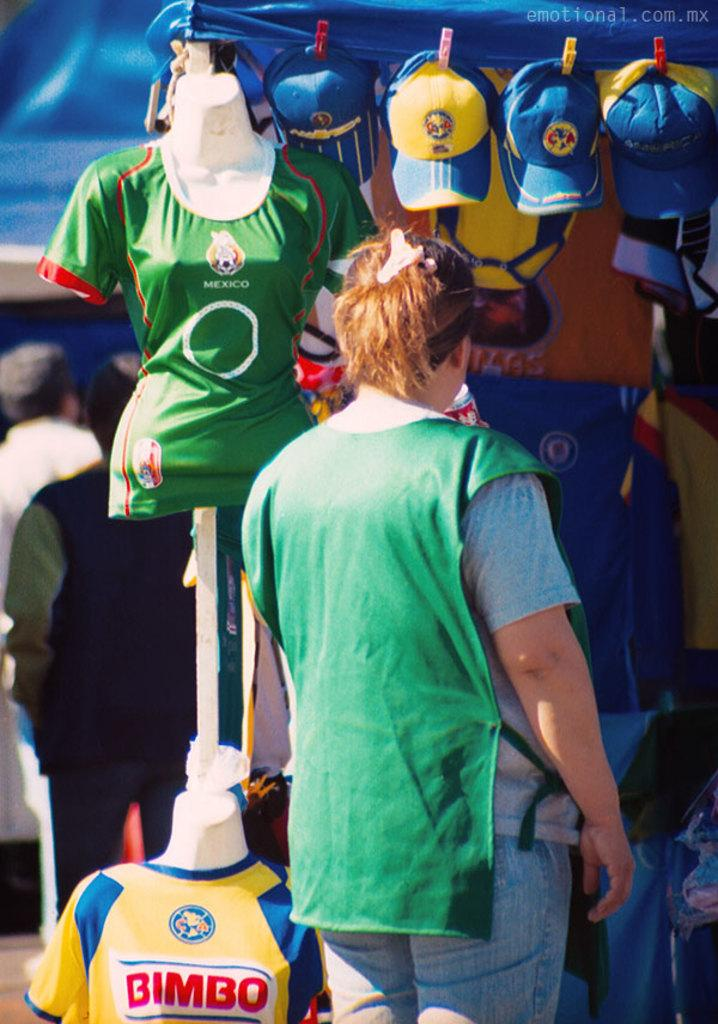<image>
Summarize the visual content of the image. A woman checks out several jerseys including ones advertising the snack food brand Bimbo. 